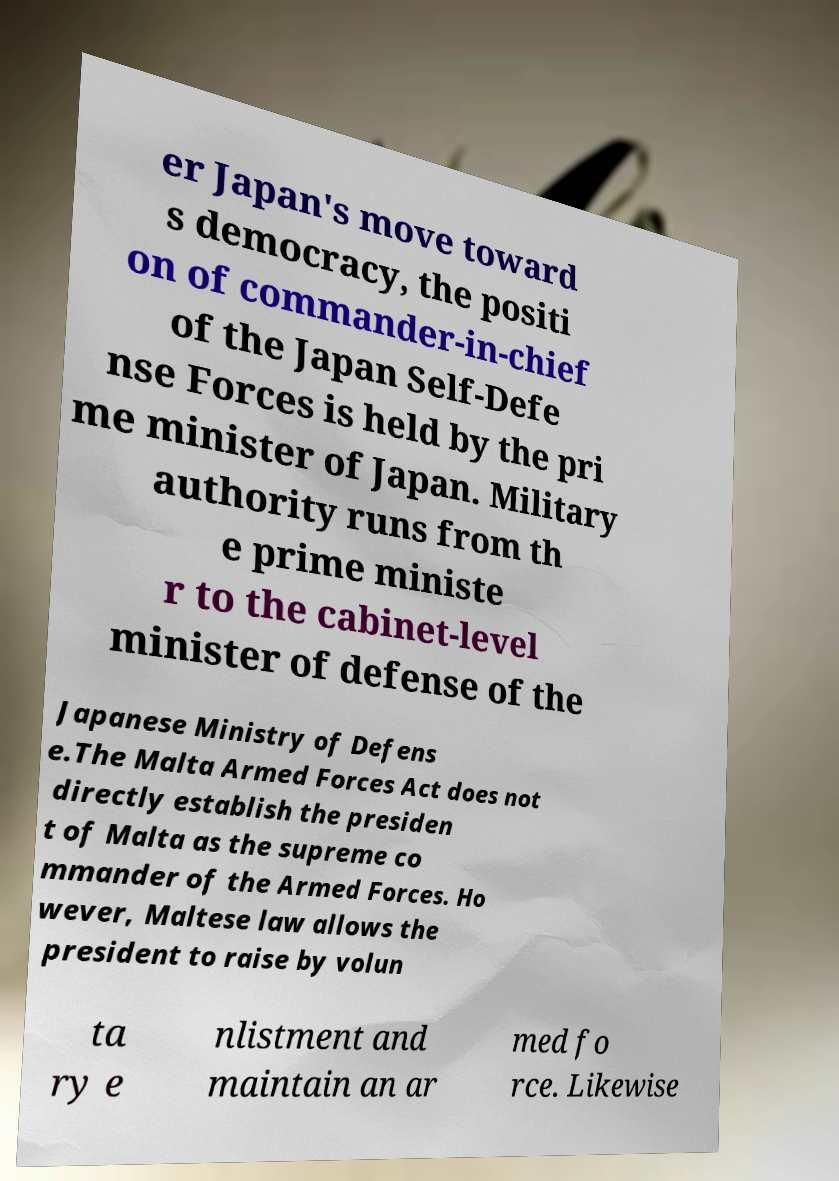What messages or text are displayed in this image? I need them in a readable, typed format. er Japan's move toward s democracy, the positi on of commander-in-chief of the Japan Self-Defe nse Forces is held by the pri me minister of Japan. Military authority runs from th e prime ministe r to the cabinet-level minister of defense of the Japanese Ministry of Defens e.The Malta Armed Forces Act does not directly establish the presiden t of Malta as the supreme co mmander of the Armed Forces. Ho wever, Maltese law allows the president to raise by volun ta ry e nlistment and maintain an ar med fo rce. Likewise 